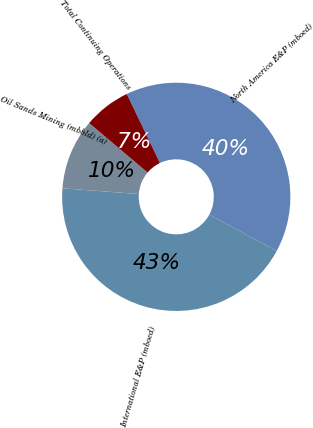Convert chart. <chart><loc_0><loc_0><loc_500><loc_500><pie_chart><fcel>North America E&P (mboed)<fcel>International E&P (mboed)<fcel>Oil Sands Mining (mbbld) (a)<fcel>Total Continuing Operations<nl><fcel>40.0%<fcel>43.33%<fcel>10.0%<fcel>6.67%<nl></chart> 